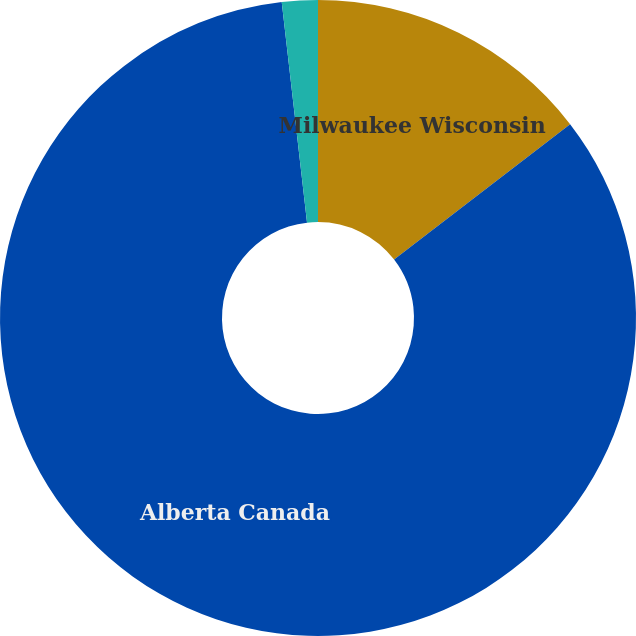Convert chart. <chart><loc_0><loc_0><loc_500><loc_500><pie_chart><fcel>Milwaukee Wisconsin<fcel>Alberta Canada<fcel>Cincinnati Ohio<nl><fcel>14.57%<fcel>83.61%<fcel>1.82%<nl></chart> 